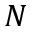Convert formula to latex. <formula><loc_0><loc_0><loc_500><loc_500>N</formula> 